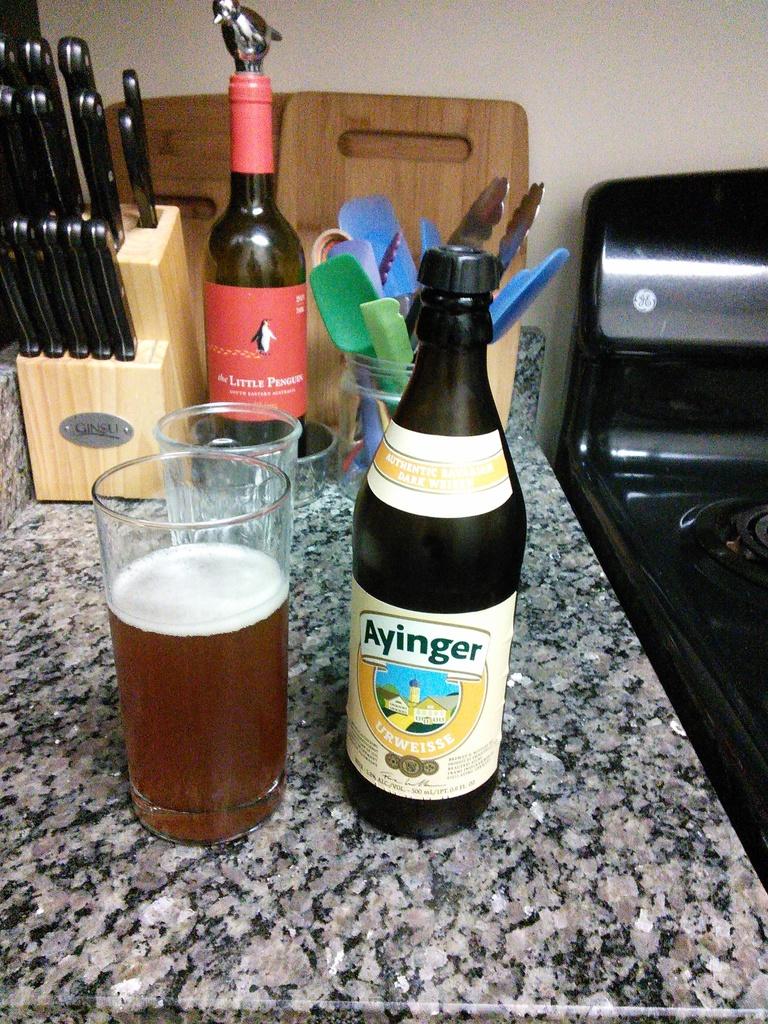What brand of knives are those?
Provide a short and direct response. Ginsu. 